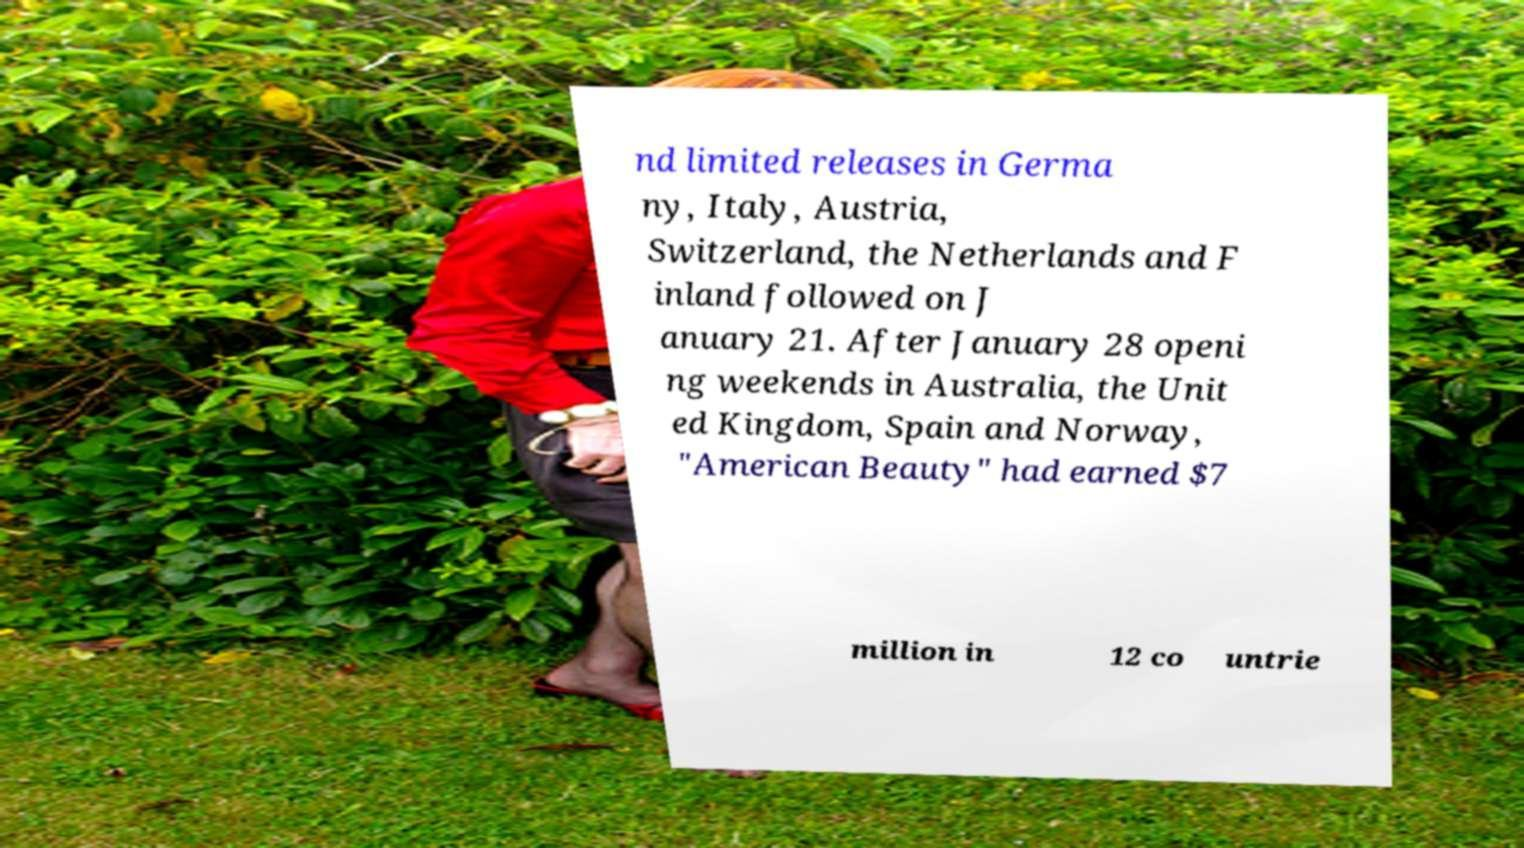There's text embedded in this image that I need extracted. Can you transcribe it verbatim? nd limited releases in Germa ny, Italy, Austria, Switzerland, the Netherlands and F inland followed on J anuary 21. After January 28 openi ng weekends in Australia, the Unit ed Kingdom, Spain and Norway, "American Beauty" had earned $7 million in 12 co untrie 